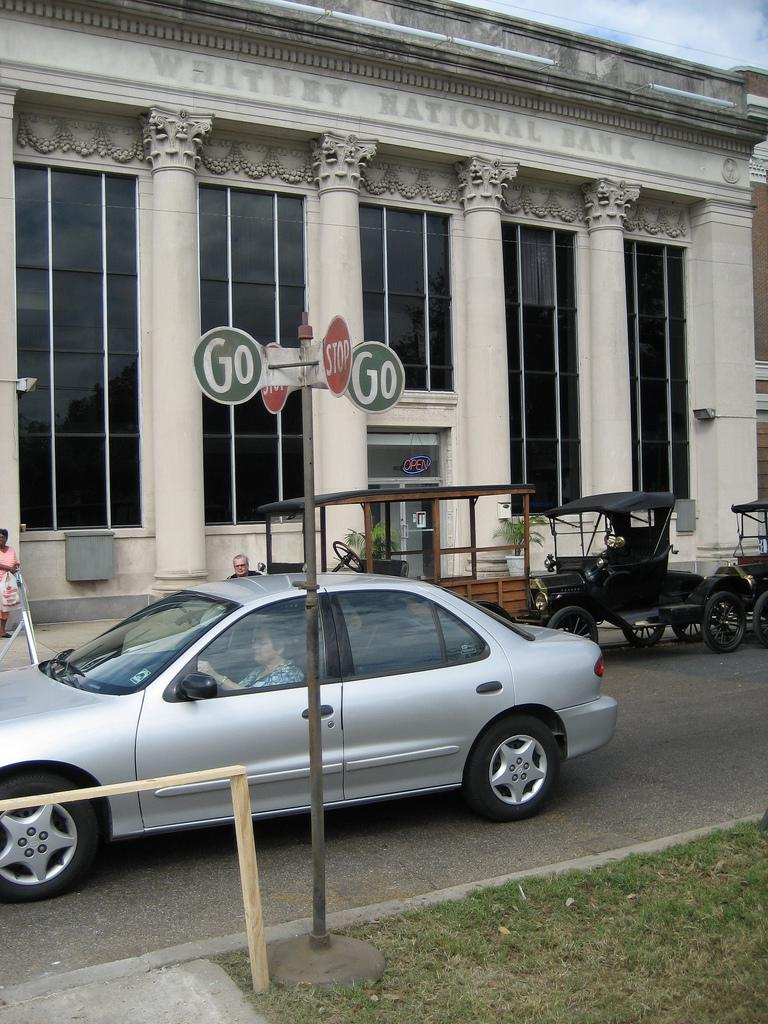Question: what color is The Whitney National Bank building?
Choices:
A. Grey.
B. Black.
C. Brown.
D. Blue.
Answer with the letter. Answer: A Question: who parked the old timers in front of the building?
Choices:
A. The Hotel Concierge.
B. Their owners.
C. The Police.
D. The Thieves.
Answer with the letter. Answer: B Question: what do the traffic signs say?
Choices:
A. Yield.
B. No right turn.
C. Deer crossing.
D. Stop and go.
Answer with the letter. Answer: D Question: where is the decal?
Choices:
A. On the back bumper of the pickup.
B. On the back of his jacket.
C. On the inside of the front windshield of the silver car.
D. On the boys baseball cap.
Answer with the letter. Answer: C Question: what is parked on the sidewalk?
Choices:
A. Bikes.
B. Antique cars.
C. Motorcycles.
D. Scooters.
Answer with the letter. Answer: B Question: how many go and stop signs are in the picture?
Choices:
A. 1.
B. 0.
C. Two each.
D. 3.
Answer with the letter. Answer: C Question: what size are the windows?
Choices:
A. Small.
B. Wide.
C. Large.
D. Tall.
Answer with the letter. Answer: C Question: what does the neon sign say?
Choices:
A. Enter.
B. Open.
C. Stop.
D. Name of bar.
Answer with the letter. Answer: B Question: what lines the doorway to the bank?
Choices:
A. Grass.
B. Flowers.
C. Potted plants.
D. Dirt.
Answer with the letter. Answer: C Question: how many antique cars are parked next to the bank?
Choices:
A. Four.
B. Five.
C. Six.
D. Three.
Answer with the letter. Answer: D Question: where is it grassy?
Choices:
A. Next to road.
B. Next to a sidewalk.
C. Under the picnic table.
D. In the front yard.
Answer with the letter. Answer: A Question: what color shirt is the woman driver wearing?
Choices:
A. Yellow and orange.
B. Blue and white.
C. Purple and pink.
D. Black and brown.
Answer with the letter. Answer: B Question: why is he waiting?
Choices:
A. Because his wife is late.
B. The line is long.
C. The Toast isn't ready.
D. The bank isn't open.
Answer with the letter. Answer: A 